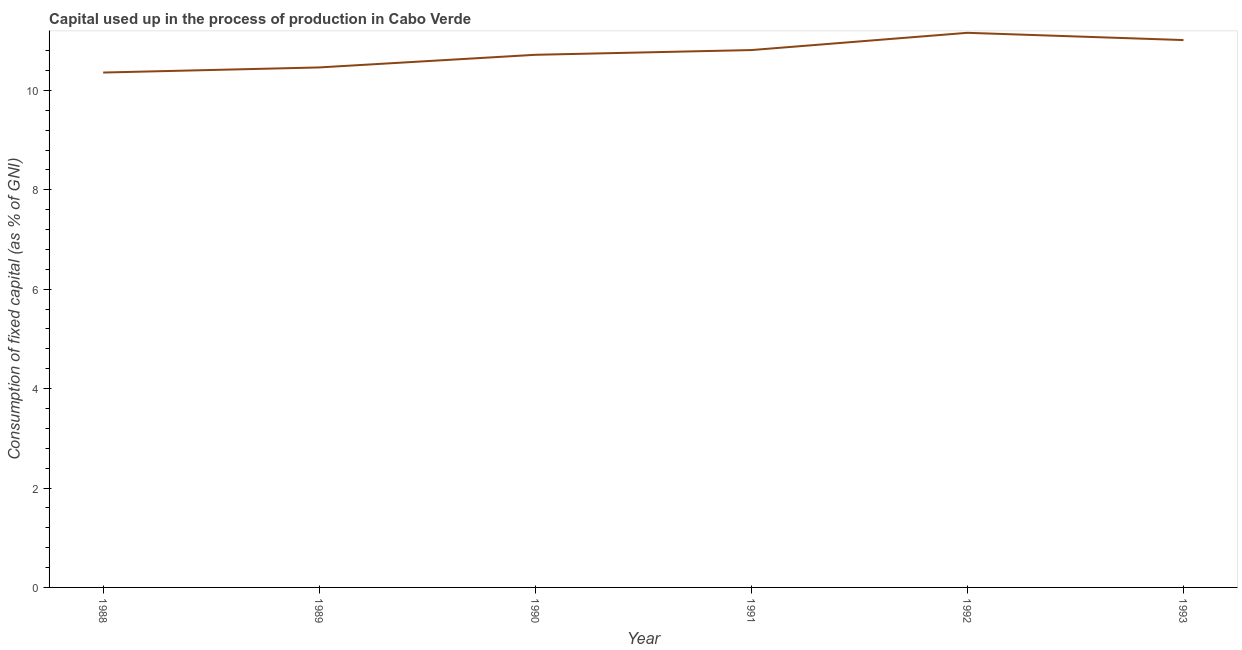What is the consumption of fixed capital in 1991?
Ensure brevity in your answer.  10.81. Across all years, what is the maximum consumption of fixed capital?
Provide a succinct answer. 11.16. Across all years, what is the minimum consumption of fixed capital?
Keep it short and to the point. 10.36. What is the sum of the consumption of fixed capital?
Give a very brief answer. 64.52. What is the difference between the consumption of fixed capital in 1991 and 1992?
Keep it short and to the point. -0.35. What is the average consumption of fixed capital per year?
Provide a short and direct response. 10.75. What is the median consumption of fixed capital?
Make the answer very short. 10.76. In how many years, is the consumption of fixed capital greater than 10.4 %?
Provide a succinct answer. 5. What is the ratio of the consumption of fixed capital in 1990 to that in 1992?
Keep it short and to the point. 0.96. Is the consumption of fixed capital in 1988 less than that in 1993?
Your answer should be compact. Yes. What is the difference between the highest and the second highest consumption of fixed capital?
Offer a terse response. 0.15. Is the sum of the consumption of fixed capital in 1989 and 1990 greater than the maximum consumption of fixed capital across all years?
Ensure brevity in your answer.  Yes. What is the difference between the highest and the lowest consumption of fixed capital?
Make the answer very short. 0.8. In how many years, is the consumption of fixed capital greater than the average consumption of fixed capital taken over all years?
Provide a short and direct response. 3. Does the consumption of fixed capital monotonically increase over the years?
Provide a short and direct response. No. What is the difference between two consecutive major ticks on the Y-axis?
Give a very brief answer. 2. Does the graph contain any zero values?
Keep it short and to the point. No. What is the title of the graph?
Your response must be concise. Capital used up in the process of production in Cabo Verde. What is the label or title of the Y-axis?
Make the answer very short. Consumption of fixed capital (as % of GNI). What is the Consumption of fixed capital (as % of GNI) of 1988?
Your response must be concise. 10.36. What is the Consumption of fixed capital (as % of GNI) of 1989?
Offer a terse response. 10.46. What is the Consumption of fixed capital (as % of GNI) in 1990?
Make the answer very short. 10.72. What is the Consumption of fixed capital (as % of GNI) of 1991?
Offer a terse response. 10.81. What is the Consumption of fixed capital (as % of GNI) in 1992?
Make the answer very short. 11.16. What is the Consumption of fixed capital (as % of GNI) in 1993?
Offer a terse response. 11.01. What is the difference between the Consumption of fixed capital (as % of GNI) in 1988 and 1989?
Offer a terse response. -0.1. What is the difference between the Consumption of fixed capital (as % of GNI) in 1988 and 1990?
Give a very brief answer. -0.36. What is the difference between the Consumption of fixed capital (as % of GNI) in 1988 and 1991?
Your answer should be very brief. -0.45. What is the difference between the Consumption of fixed capital (as % of GNI) in 1988 and 1992?
Your response must be concise. -0.8. What is the difference between the Consumption of fixed capital (as % of GNI) in 1988 and 1993?
Offer a very short reply. -0.65. What is the difference between the Consumption of fixed capital (as % of GNI) in 1989 and 1990?
Ensure brevity in your answer.  -0.25. What is the difference between the Consumption of fixed capital (as % of GNI) in 1989 and 1991?
Keep it short and to the point. -0.35. What is the difference between the Consumption of fixed capital (as % of GNI) in 1989 and 1992?
Keep it short and to the point. -0.7. What is the difference between the Consumption of fixed capital (as % of GNI) in 1989 and 1993?
Offer a terse response. -0.55. What is the difference between the Consumption of fixed capital (as % of GNI) in 1990 and 1991?
Your answer should be very brief. -0.1. What is the difference between the Consumption of fixed capital (as % of GNI) in 1990 and 1992?
Offer a terse response. -0.44. What is the difference between the Consumption of fixed capital (as % of GNI) in 1990 and 1993?
Offer a terse response. -0.3. What is the difference between the Consumption of fixed capital (as % of GNI) in 1991 and 1992?
Provide a short and direct response. -0.35. What is the difference between the Consumption of fixed capital (as % of GNI) in 1991 and 1993?
Provide a succinct answer. -0.2. What is the difference between the Consumption of fixed capital (as % of GNI) in 1992 and 1993?
Keep it short and to the point. 0.15. What is the ratio of the Consumption of fixed capital (as % of GNI) in 1988 to that in 1990?
Offer a very short reply. 0.97. What is the ratio of the Consumption of fixed capital (as % of GNI) in 1988 to that in 1991?
Offer a terse response. 0.96. What is the ratio of the Consumption of fixed capital (as % of GNI) in 1988 to that in 1992?
Keep it short and to the point. 0.93. What is the ratio of the Consumption of fixed capital (as % of GNI) in 1988 to that in 1993?
Ensure brevity in your answer.  0.94. What is the ratio of the Consumption of fixed capital (as % of GNI) in 1989 to that in 1990?
Ensure brevity in your answer.  0.98. What is the ratio of the Consumption of fixed capital (as % of GNI) in 1989 to that in 1991?
Make the answer very short. 0.97. What is the ratio of the Consumption of fixed capital (as % of GNI) in 1989 to that in 1992?
Your answer should be compact. 0.94. What is the ratio of the Consumption of fixed capital (as % of GNI) in 1989 to that in 1993?
Your answer should be very brief. 0.95. What is the ratio of the Consumption of fixed capital (as % of GNI) in 1990 to that in 1993?
Your answer should be very brief. 0.97. 